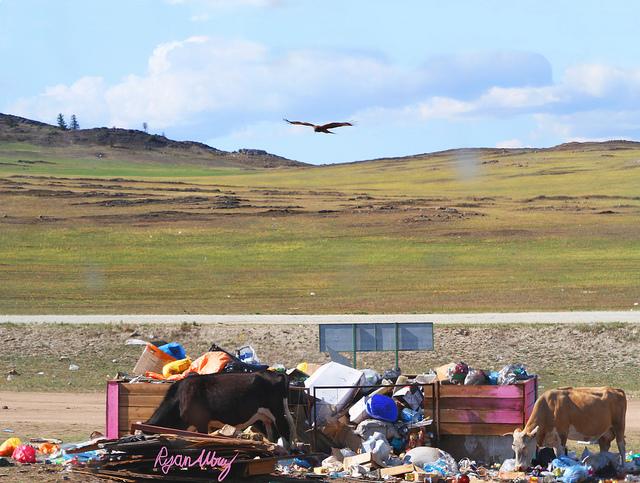What kind of animal is on the ground?
Short answer required. Cow. Are the cows walking in junk?
Short answer required. Yes. Can any of these animals fly?
Keep it brief. Yes. 